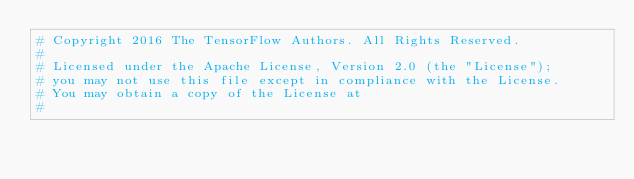Convert code to text. <code><loc_0><loc_0><loc_500><loc_500><_Python_># Copyright 2016 The TensorFlow Authors. All Rights Reserved.
#
# Licensed under the Apache License, Version 2.0 (the "License");
# you may not use this file except in compliance with the License.
# You may obtain a copy of the License at
#</code> 